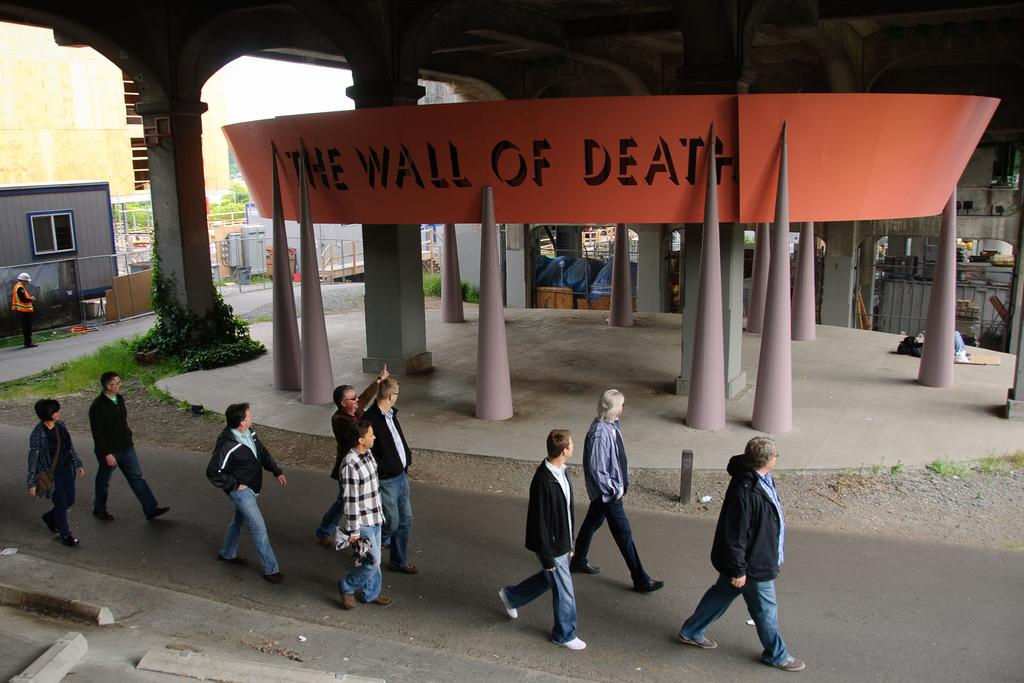What are the people in the image doing? The people in the image are walking on a road. What can be seen in the background of the image? In the background, there are poles, a banner, plants, and sheds. What is written on the banner? The banner has text on it. Can you tell me how many pigs are wearing jeans in the image? There are no pigs or jeans present in the image. What example can be seen in the image? The image does not show an example; it depicts people walking on a road and background elements. 